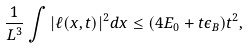<formula> <loc_0><loc_0><loc_500><loc_500>\frac { 1 } { L ^ { 3 } } \int | \ell ( x , t ) | ^ { 2 } d x \leq ( 4 E _ { 0 } + t \epsilon _ { B } ) t ^ { 2 } ,</formula> 